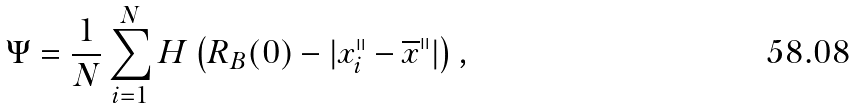<formula> <loc_0><loc_0><loc_500><loc_500>\Psi = \frac { 1 } { N } \sum _ { i = 1 } ^ { N } H \left ( R _ { B } ( 0 ) - | x ^ { \shortparallel } _ { i } - \overline { x } ^ { \shortparallel } | \right ) ,</formula> 